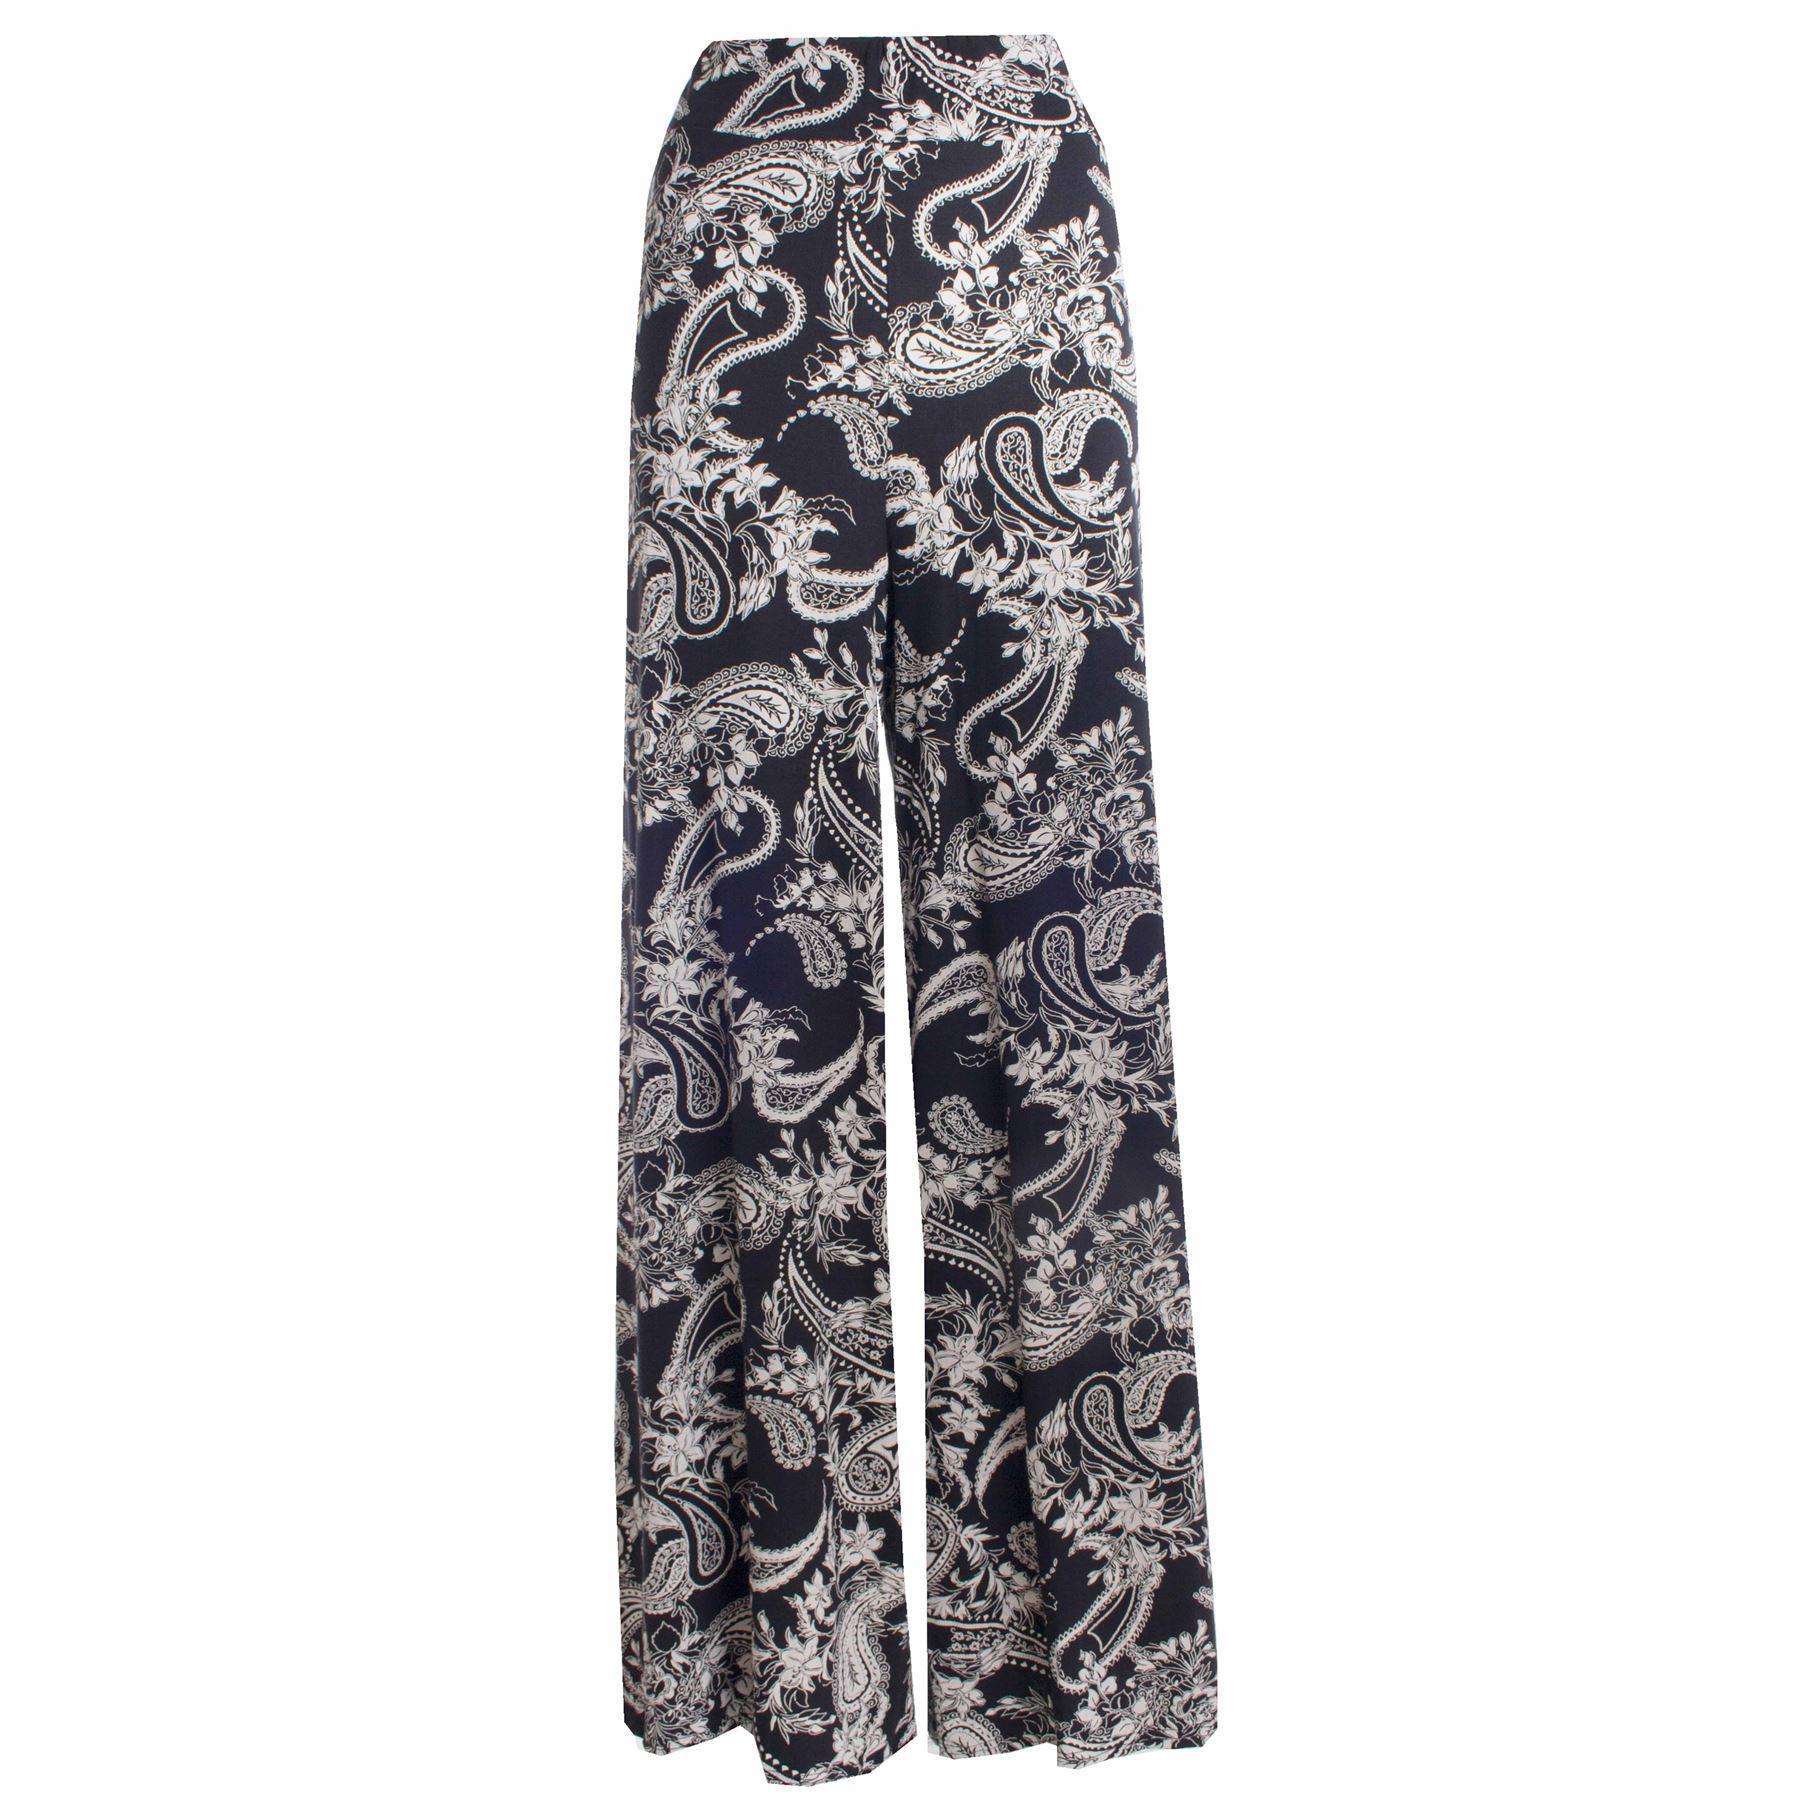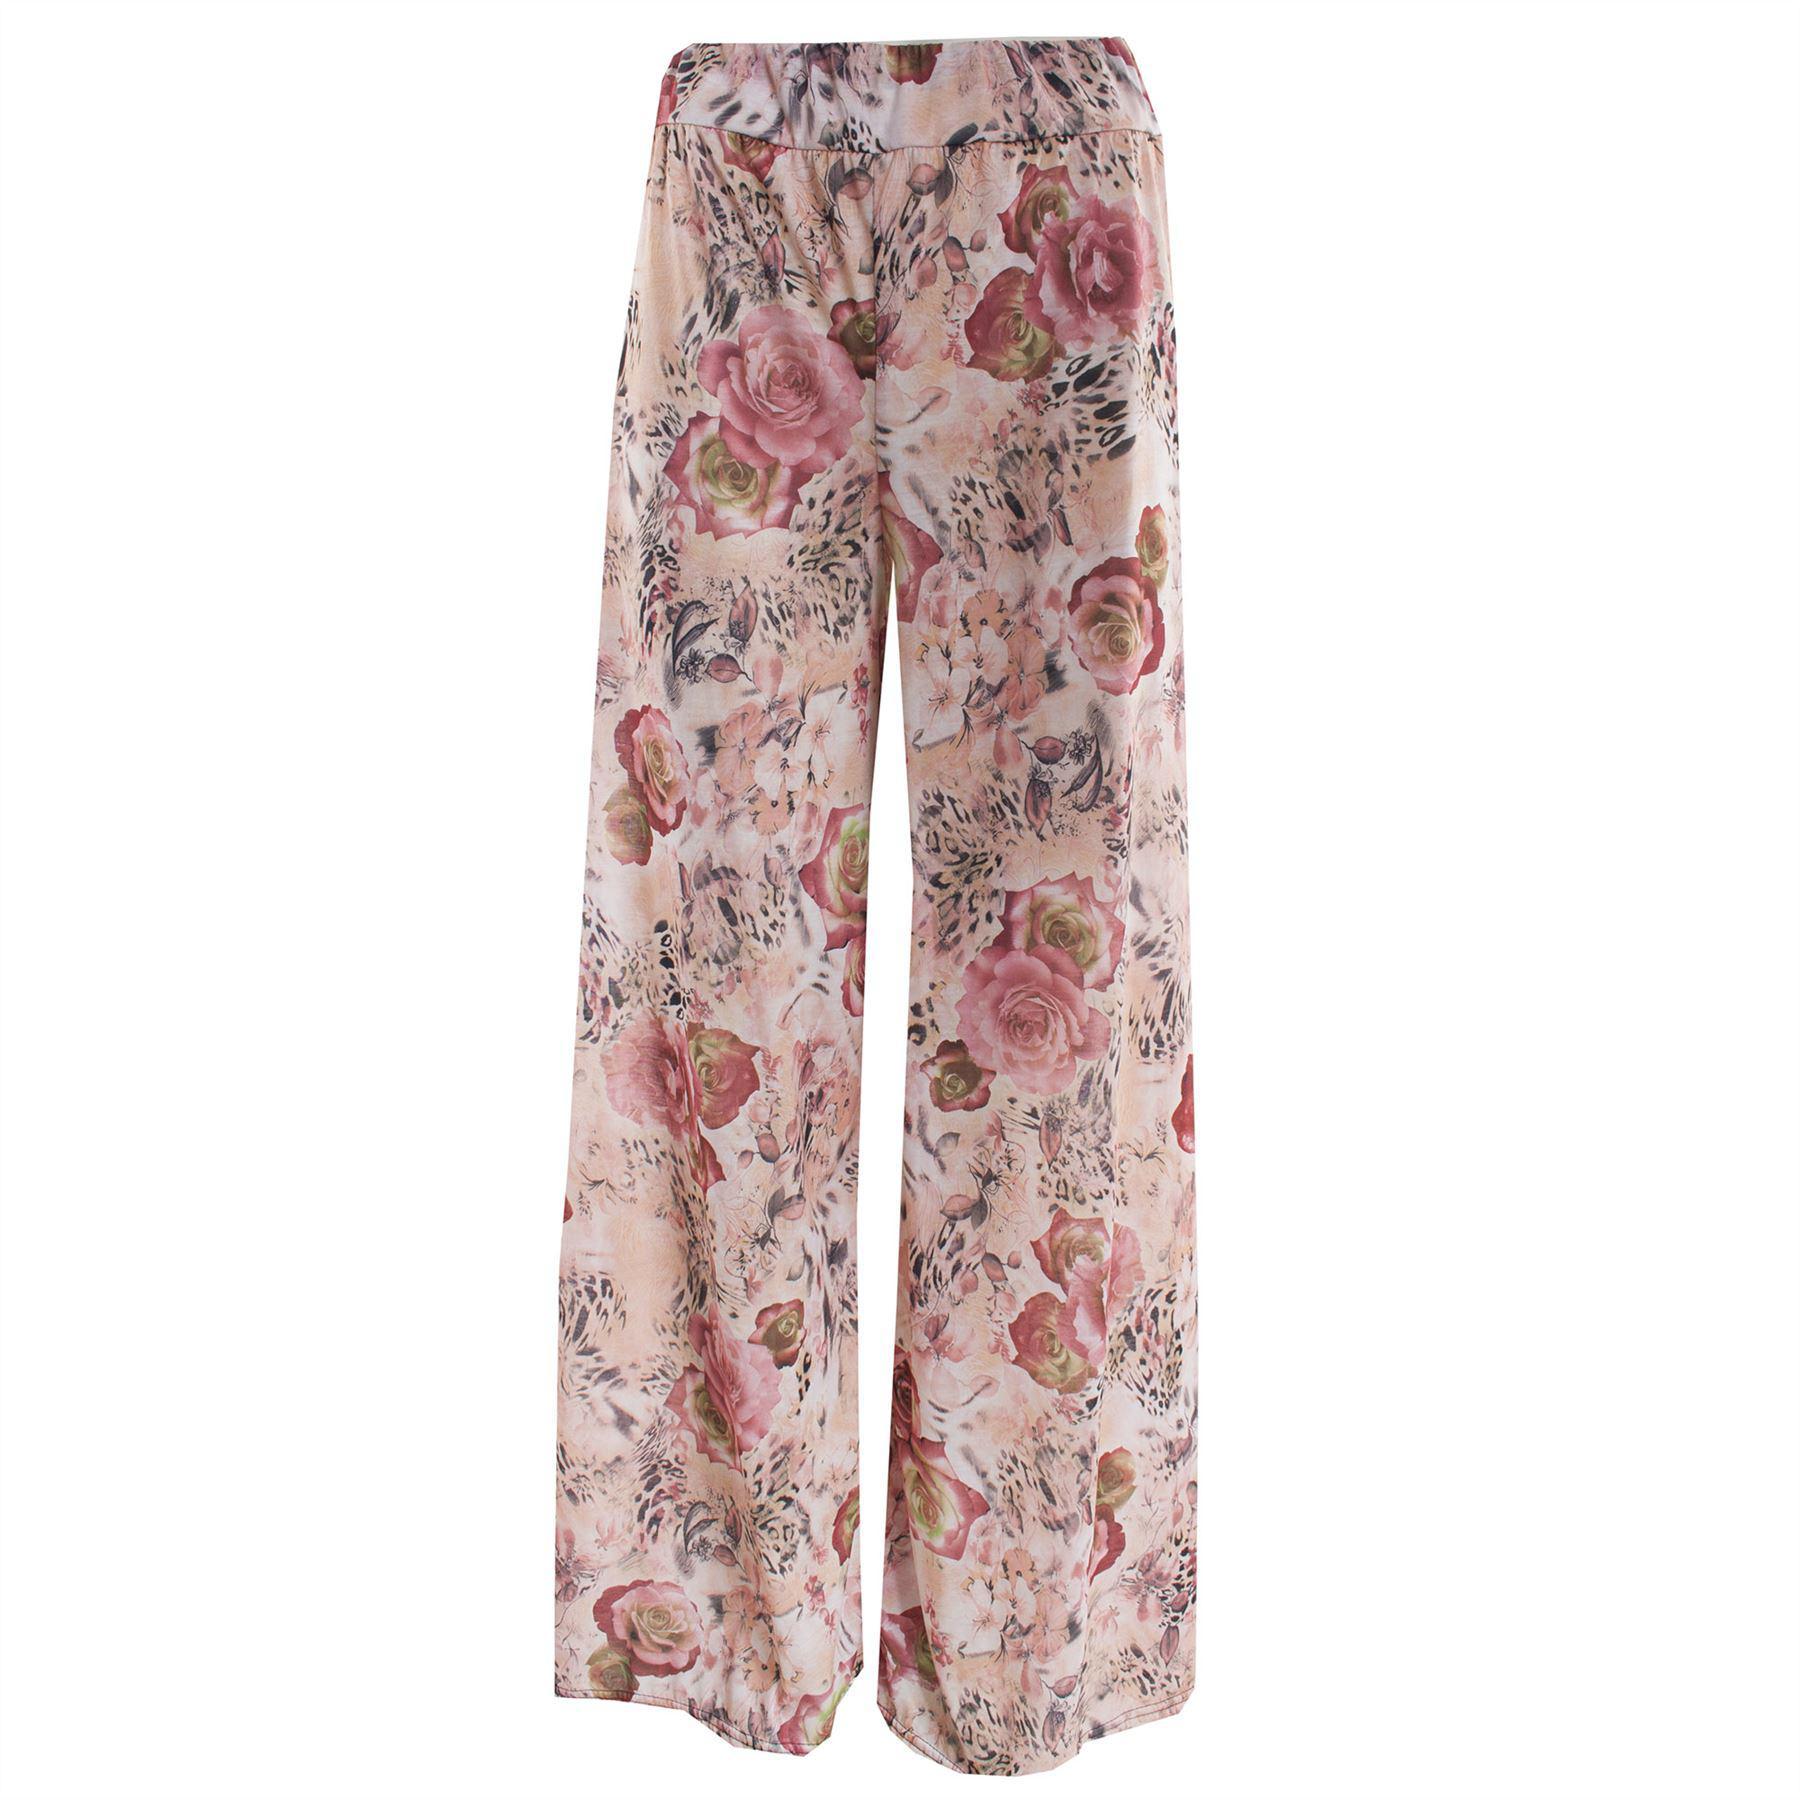The first image is the image on the left, the second image is the image on the right. Assess this claim about the two images: "A person is wearing the clothing on the right.". Correct or not? Answer yes or no. No. 